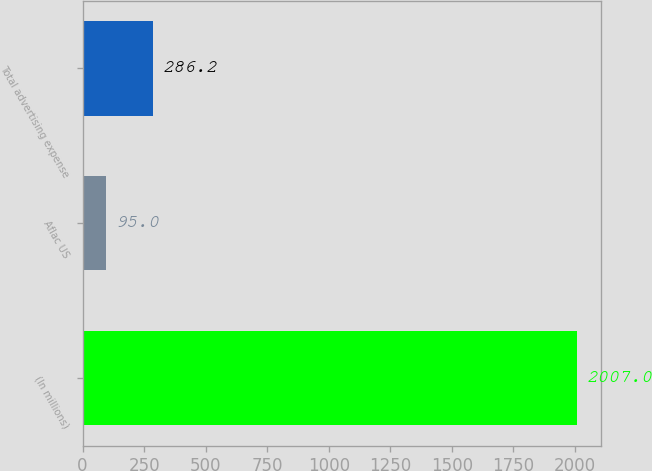Convert chart to OTSL. <chart><loc_0><loc_0><loc_500><loc_500><bar_chart><fcel>(In millions)<fcel>Aflac US<fcel>Total advertising expense<nl><fcel>2007<fcel>95<fcel>286.2<nl></chart> 